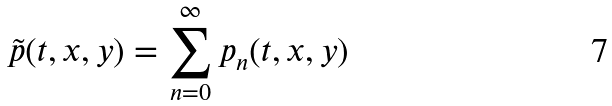<formula> <loc_0><loc_0><loc_500><loc_500>\tilde { p } ( t , x , y ) = \sum _ { n = 0 } ^ { \infty } p _ { n } ( t , x , y )</formula> 